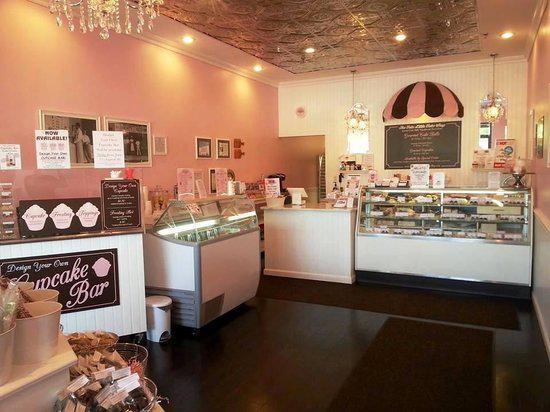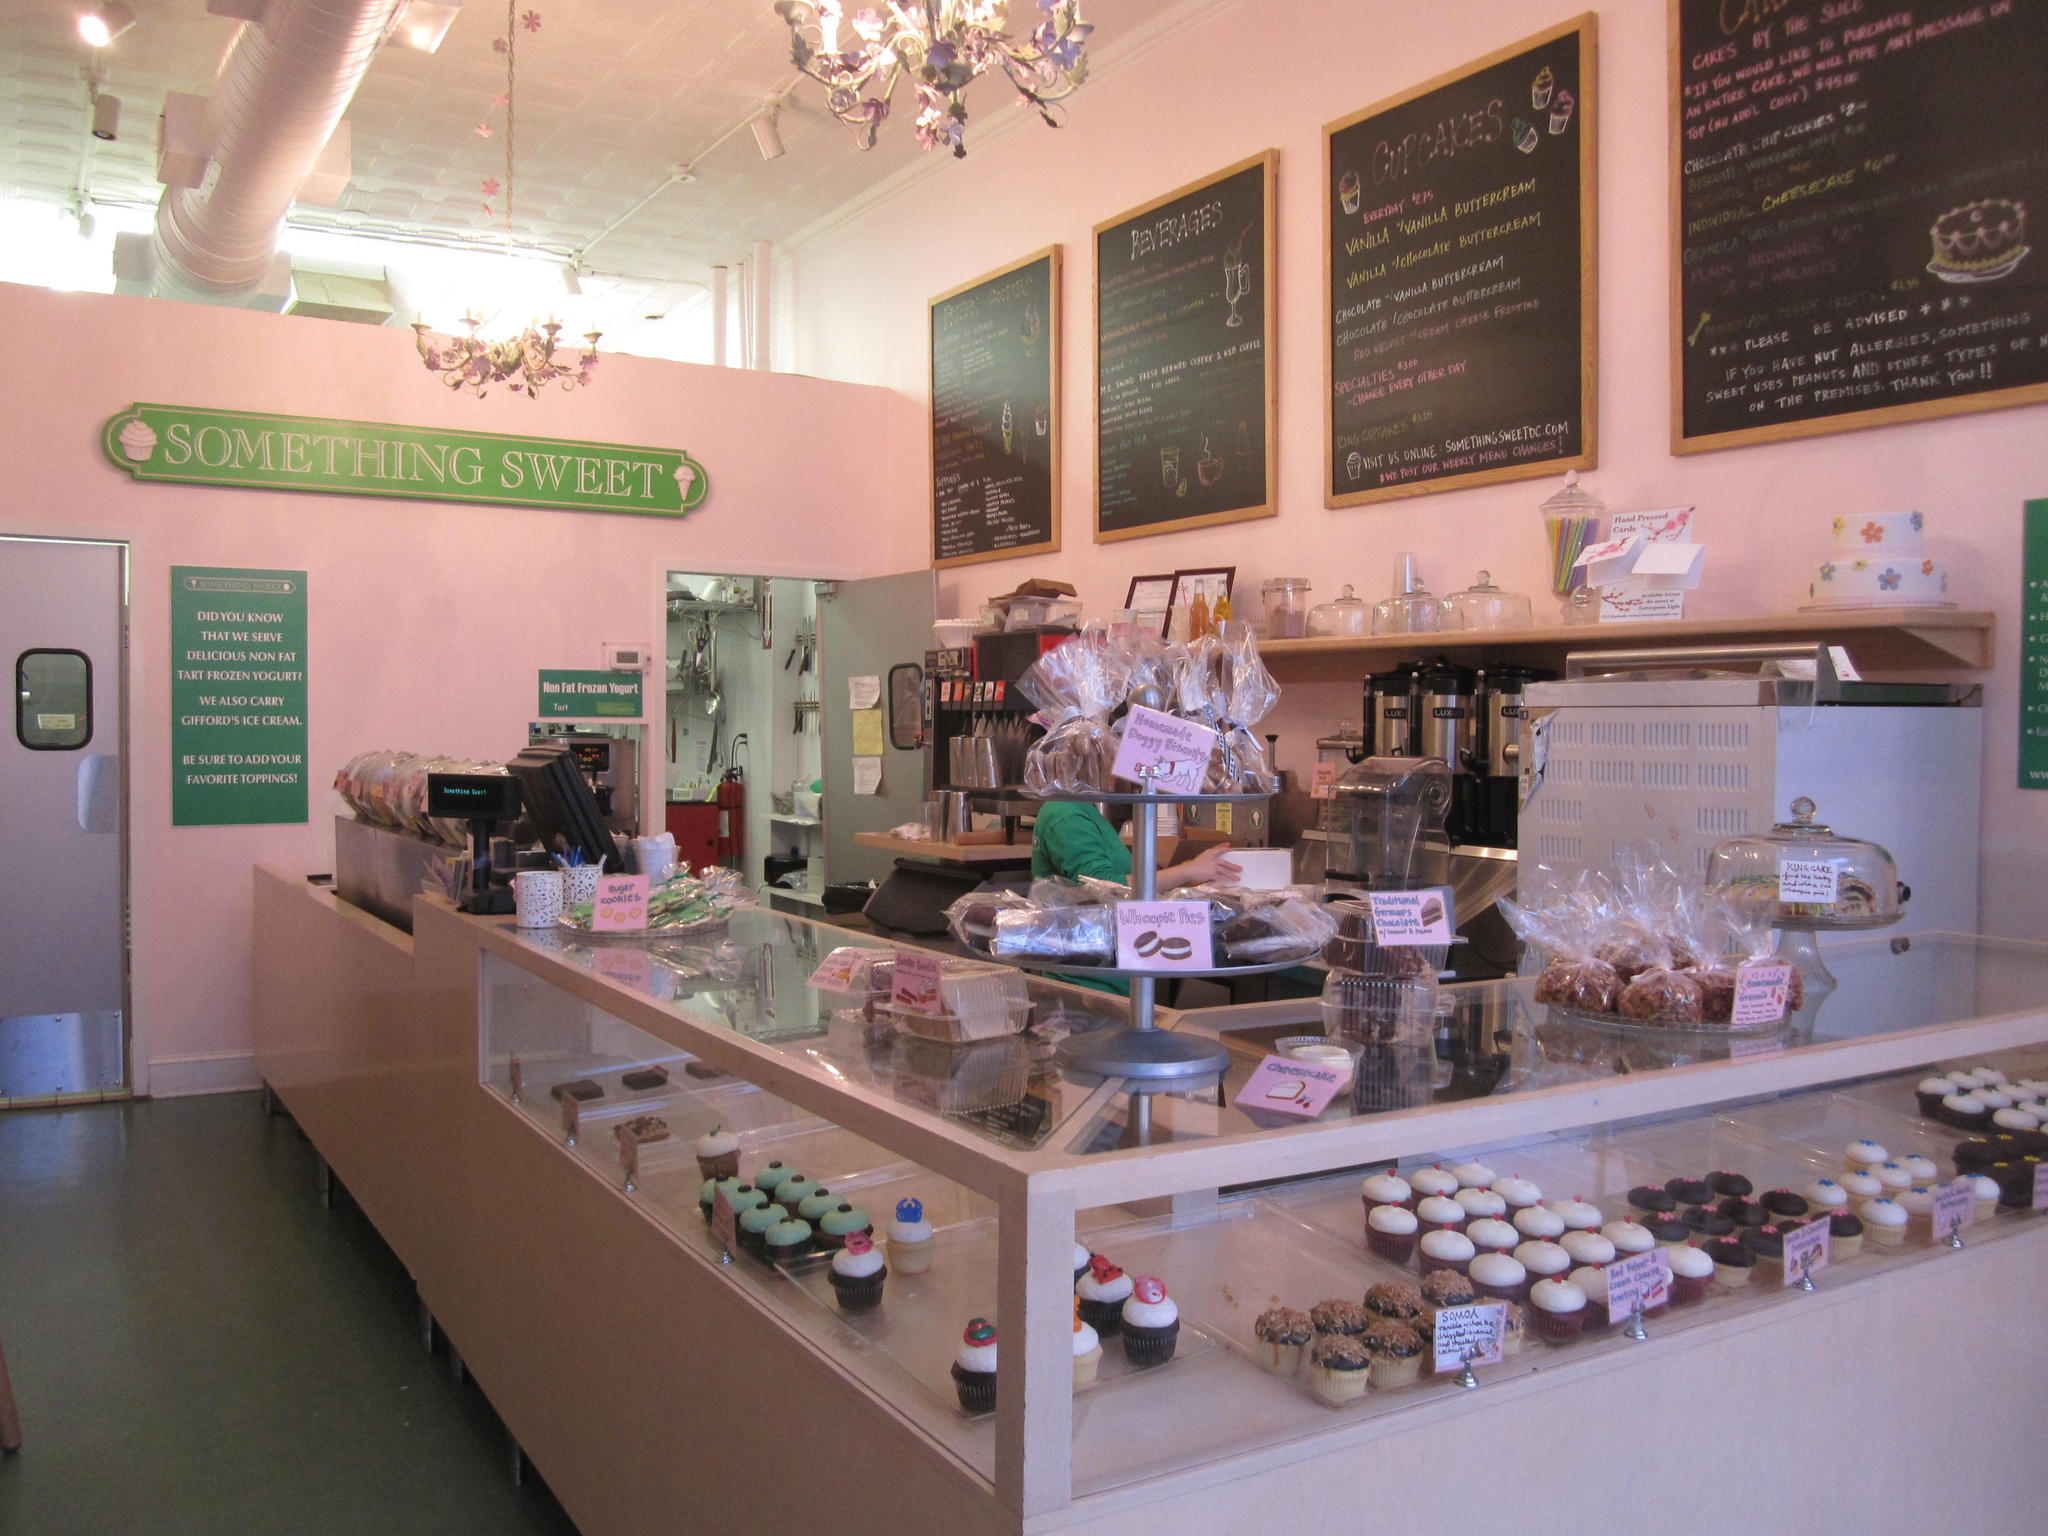The first image is the image on the left, the second image is the image on the right. Considering the images on both sides, is "An image contains a view of a storefront from an outside perspective." valid? Answer yes or no. No. The first image is the image on the left, the second image is the image on the right. Given the left and right images, does the statement "There are tables and chairs for the customers." hold true? Answer yes or no. No. 